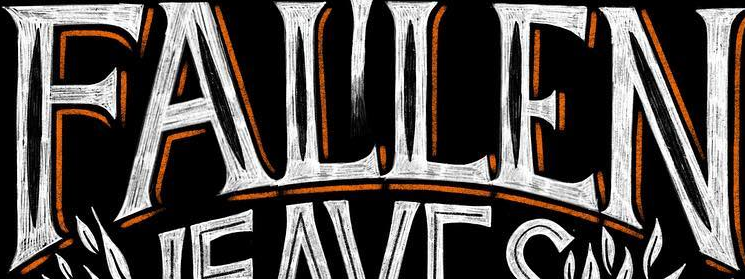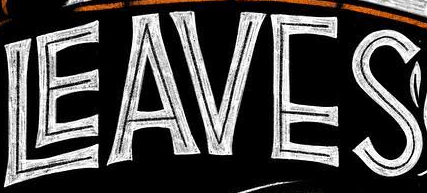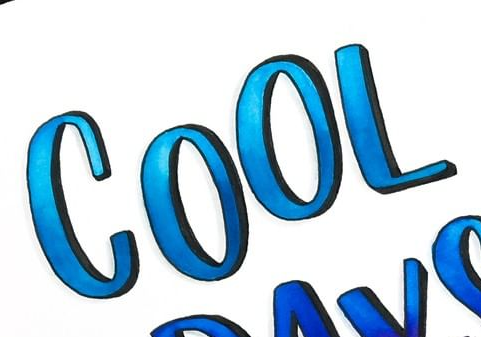What text is displayed in these images sequentially, separated by a semicolon? FALLEN; LEAVES; COOL 